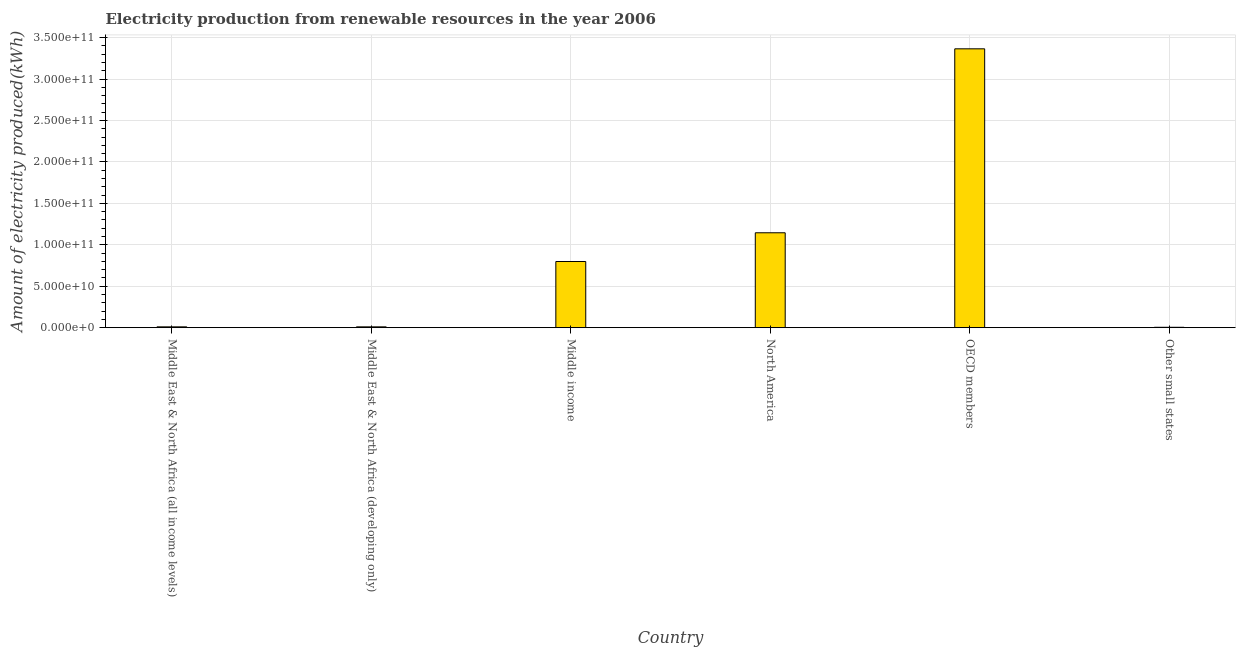Does the graph contain grids?
Keep it short and to the point. Yes. What is the title of the graph?
Your response must be concise. Electricity production from renewable resources in the year 2006. What is the label or title of the Y-axis?
Ensure brevity in your answer.  Amount of electricity produced(kWh). What is the amount of electricity produced in Middle East & North Africa (developing only)?
Ensure brevity in your answer.  9.71e+08. Across all countries, what is the maximum amount of electricity produced?
Your response must be concise. 3.37e+11. Across all countries, what is the minimum amount of electricity produced?
Your answer should be compact. 4.54e+08. In which country was the amount of electricity produced maximum?
Keep it short and to the point. OECD members. In which country was the amount of electricity produced minimum?
Your response must be concise. Other small states. What is the sum of the amount of electricity produced?
Keep it short and to the point. 5.33e+11. What is the difference between the amount of electricity produced in Middle East & North Africa (all income levels) and Other small states?
Provide a succinct answer. 5.27e+08. What is the average amount of electricity produced per country?
Give a very brief answer. 8.89e+1. What is the median amount of electricity produced?
Make the answer very short. 4.04e+1. What is the ratio of the amount of electricity produced in OECD members to that in Other small states?
Ensure brevity in your answer.  741.36. Is the amount of electricity produced in Middle East & North Africa (all income levels) less than that in Other small states?
Your response must be concise. No. Is the difference between the amount of electricity produced in Middle East & North Africa (all income levels) and North America greater than the difference between any two countries?
Keep it short and to the point. No. What is the difference between the highest and the second highest amount of electricity produced?
Keep it short and to the point. 2.22e+11. Is the sum of the amount of electricity produced in Middle East & North Africa (developing only) and OECD members greater than the maximum amount of electricity produced across all countries?
Give a very brief answer. Yes. What is the difference between the highest and the lowest amount of electricity produced?
Ensure brevity in your answer.  3.36e+11. How many countries are there in the graph?
Your answer should be compact. 6. Are the values on the major ticks of Y-axis written in scientific E-notation?
Offer a terse response. Yes. What is the Amount of electricity produced(kWh) of Middle East & North Africa (all income levels)?
Provide a succinct answer. 9.81e+08. What is the Amount of electricity produced(kWh) in Middle East & North Africa (developing only)?
Keep it short and to the point. 9.71e+08. What is the Amount of electricity produced(kWh) in Middle income?
Your response must be concise. 7.99e+1. What is the Amount of electricity produced(kWh) of North America?
Your answer should be compact. 1.15e+11. What is the Amount of electricity produced(kWh) in OECD members?
Keep it short and to the point. 3.37e+11. What is the Amount of electricity produced(kWh) in Other small states?
Give a very brief answer. 4.54e+08. What is the difference between the Amount of electricity produced(kWh) in Middle East & North Africa (all income levels) and Middle East & North Africa (developing only)?
Ensure brevity in your answer.  1.00e+07. What is the difference between the Amount of electricity produced(kWh) in Middle East & North Africa (all income levels) and Middle income?
Your response must be concise. -7.89e+1. What is the difference between the Amount of electricity produced(kWh) in Middle East & North Africa (all income levels) and North America?
Ensure brevity in your answer.  -1.14e+11. What is the difference between the Amount of electricity produced(kWh) in Middle East & North Africa (all income levels) and OECD members?
Provide a short and direct response. -3.36e+11. What is the difference between the Amount of electricity produced(kWh) in Middle East & North Africa (all income levels) and Other small states?
Give a very brief answer. 5.27e+08. What is the difference between the Amount of electricity produced(kWh) in Middle East & North Africa (developing only) and Middle income?
Your response must be concise. -7.89e+1. What is the difference between the Amount of electricity produced(kWh) in Middle East & North Africa (developing only) and North America?
Ensure brevity in your answer.  -1.14e+11. What is the difference between the Amount of electricity produced(kWh) in Middle East & North Africa (developing only) and OECD members?
Offer a terse response. -3.36e+11. What is the difference between the Amount of electricity produced(kWh) in Middle East & North Africa (developing only) and Other small states?
Offer a terse response. 5.17e+08. What is the difference between the Amount of electricity produced(kWh) in Middle income and North America?
Offer a very short reply. -3.47e+1. What is the difference between the Amount of electricity produced(kWh) in Middle income and OECD members?
Make the answer very short. -2.57e+11. What is the difference between the Amount of electricity produced(kWh) in Middle income and Other small states?
Give a very brief answer. 7.94e+1. What is the difference between the Amount of electricity produced(kWh) in North America and OECD members?
Offer a very short reply. -2.22e+11. What is the difference between the Amount of electricity produced(kWh) in North America and Other small states?
Offer a very short reply. 1.14e+11. What is the difference between the Amount of electricity produced(kWh) in OECD members and Other small states?
Make the answer very short. 3.36e+11. What is the ratio of the Amount of electricity produced(kWh) in Middle East & North Africa (all income levels) to that in Middle East & North Africa (developing only)?
Your answer should be very brief. 1.01. What is the ratio of the Amount of electricity produced(kWh) in Middle East & North Africa (all income levels) to that in Middle income?
Keep it short and to the point. 0.01. What is the ratio of the Amount of electricity produced(kWh) in Middle East & North Africa (all income levels) to that in North America?
Give a very brief answer. 0.01. What is the ratio of the Amount of electricity produced(kWh) in Middle East & North Africa (all income levels) to that in OECD members?
Provide a short and direct response. 0. What is the ratio of the Amount of electricity produced(kWh) in Middle East & North Africa (all income levels) to that in Other small states?
Offer a very short reply. 2.16. What is the ratio of the Amount of electricity produced(kWh) in Middle East & North Africa (developing only) to that in Middle income?
Offer a very short reply. 0.01. What is the ratio of the Amount of electricity produced(kWh) in Middle East & North Africa (developing only) to that in North America?
Provide a succinct answer. 0.01. What is the ratio of the Amount of electricity produced(kWh) in Middle East & North Africa (developing only) to that in OECD members?
Offer a very short reply. 0. What is the ratio of the Amount of electricity produced(kWh) in Middle East & North Africa (developing only) to that in Other small states?
Make the answer very short. 2.14. What is the ratio of the Amount of electricity produced(kWh) in Middle income to that in North America?
Give a very brief answer. 0.7. What is the ratio of the Amount of electricity produced(kWh) in Middle income to that in OECD members?
Offer a terse response. 0.24. What is the ratio of the Amount of electricity produced(kWh) in Middle income to that in Other small states?
Offer a terse response. 175.9. What is the ratio of the Amount of electricity produced(kWh) in North America to that in OECD members?
Give a very brief answer. 0.34. What is the ratio of the Amount of electricity produced(kWh) in North America to that in Other small states?
Ensure brevity in your answer.  252.28. What is the ratio of the Amount of electricity produced(kWh) in OECD members to that in Other small states?
Your answer should be compact. 741.36. 